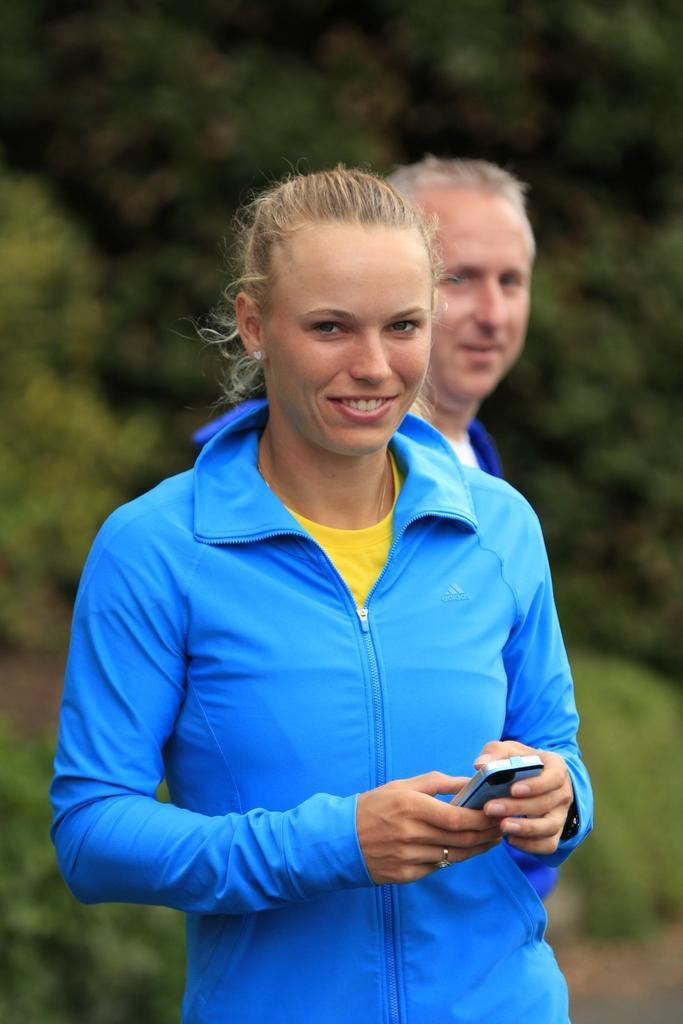Can you describe this image briefly? In this image in the foreground there is one woman and she is holding a mobile phone and smiling, and in the background there is one man and some trees. 